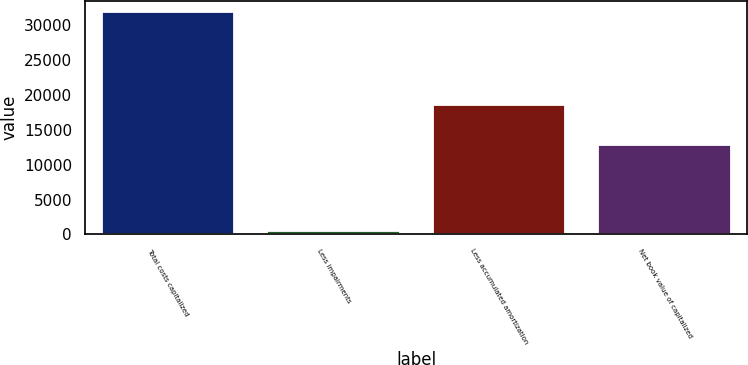Convert chart. <chart><loc_0><loc_0><loc_500><loc_500><bar_chart><fcel>Total costs capitalized<fcel>Less impairments<fcel>Less accumulated amortization<fcel>Net book value of capitalized<nl><fcel>31856<fcel>485<fcel>18598<fcel>12773<nl></chart> 